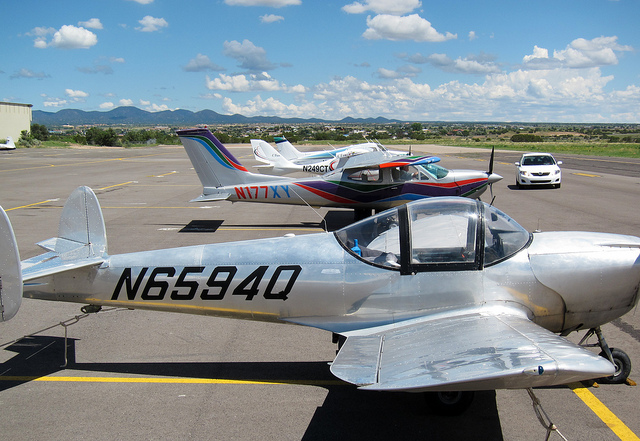How does the weather seem to affect flying conditions today? Based on the image, the weather conditions appear favorable for flying, with a clear sky and visible cumulus clouds indicating good weather patterns. Also, the presence of multiple planes on the tarmac suggests active flying operations, which would not be so if the weather conditions were poor. Are clouds like those in the image an indicator of any specific weather conditions? Cumulus clouds, like the ones visible in the image, typically indicate fair weather and are often present on sunny days with good atmospheric stability. They tend to develop due to localized convection as the sun heats the ground, causing the air to rise and cool, forming these fluffy, cotton-like clouds. 